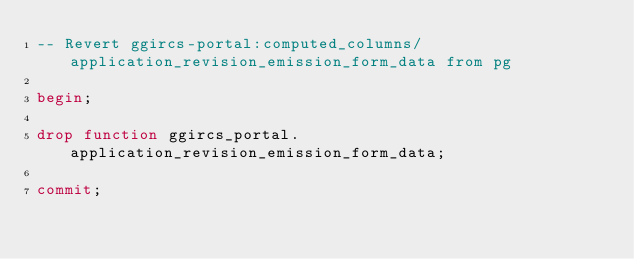<code> <loc_0><loc_0><loc_500><loc_500><_SQL_>-- Revert ggircs-portal:computed_columns/application_revision_emission_form_data from pg

begin;

drop function ggircs_portal.application_revision_emission_form_data;

commit;
</code> 